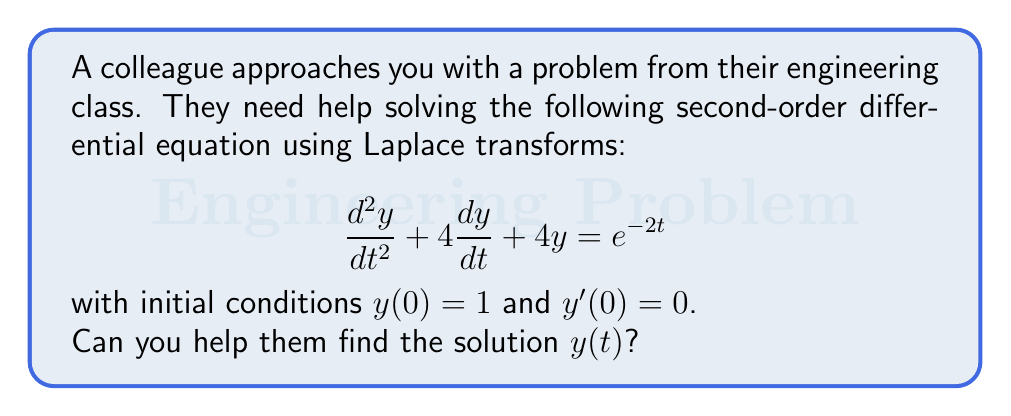Give your solution to this math problem. Let's solve this step-by-step using Laplace transforms:

1) First, let's take the Laplace transform of both sides of the equation. Let $Y(s) = \mathcal{L}\{y(t)\}$.

   $\mathcal{L}\{\frac{d^2y}{dt^2} + 4\frac{dy}{dt} + 4y\} = \mathcal{L}\{e^{-2t}\}$

2) Using Laplace transform properties:

   $[s^2Y(s) - sy(0) - y'(0)] + 4[sY(s) - y(0)] + 4Y(s) = \frac{1}{s+2}$

3) Substitute the initial conditions $y(0) = 1$ and $y'(0) = 0$:

   $s^2Y(s) - s + 4sY(s) - 4 + 4Y(s) = \frac{1}{s+2}$

4) Simplify:

   $(s^2 + 4s + 4)Y(s) = \frac{1}{s+2} + s + 4$

5) Factor out $Y(s)$:

   $Y(s)[(s+2)^2] = \frac{1}{s+2} + s + 4$

6) Solve for $Y(s)$:

   $Y(s) = \frac{1}{(s+2)^3} + \frac{s+4}{(s+2)^2}$

7) Now we need to find the inverse Laplace transform. Let's break this into partial fractions:

   $Y(s) = \frac{1}{(s+2)^3} + \frac{1}{s+2} + \frac{3}{(s+2)^2}$

8) Using inverse Laplace transform properties:

   $y(t) = \mathcal{L}^{-1}\{\frac{1}{(s+2)^3}\} + \mathcal{L}^{-1}\{\frac{1}{s+2}\} + \mathcal{L}^{-1}\{\frac{3}{(s+2)^2}\}$

9) Applying the inverse transforms:

   $y(t) = \frac{1}{2}t^2e^{-2t} + e^{-2t} + 3te^{-2t}$

10) Simplify:

    $y(t) = e^{-2t}(\frac{1}{2}t^2 + 3t + 1)$

This is our final solution.
Answer: $y(t) = e^{-2t}(\frac{1}{2}t^2 + 3t + 1)$ 